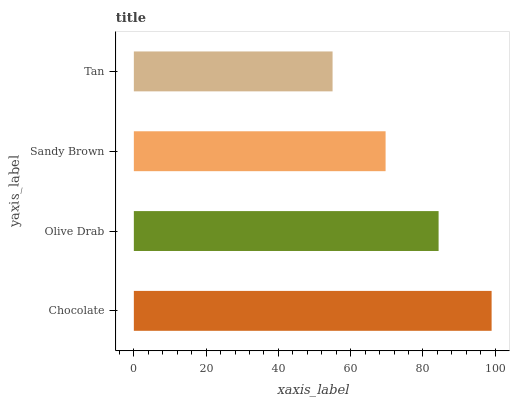Is Tan the minimum?
Answer yes or no. Yes. Is Chocolate the maximum?
Answer yes or no. Yes. Is Olive Drab the minimum?
Answer yes or no. No. Is Olive Drab the maximum?
Answer yes or no. No. Is Chocolate greater than Olive Drab?
Answer yes or no. Yes. Is Olive Drab less than Chocolate?
Answer yes or no. Yes. Is Olive Drab greater than Chocolate?
Answer yes or no. No. Is Chocolate less than Olive Drab?
Answer yes or no. No. Is Olive Drab the high median?
Answer yes or no. Yes. Is Sandy Brown the low median?
Answer yes or no. Yes. Is Tan the high median?
Answer yes or no. No. Is Tan the low median?
Answer yes or no. No. 